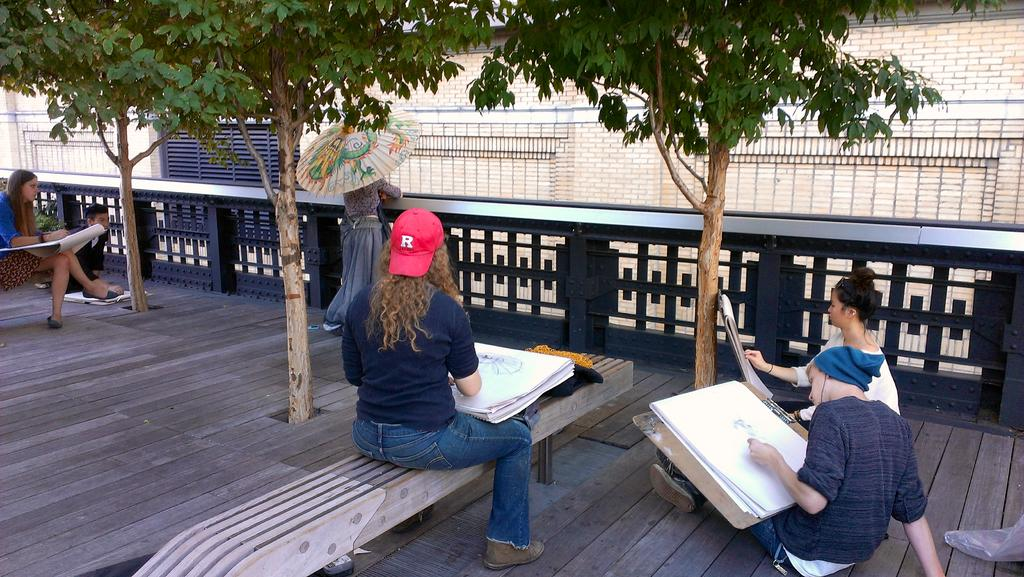Who or what can be seen in the image? There are people in the image. What are the people doing in the image? The people are on a path. What are the people holding in their hands? Most of the people are holding papers in their hands. How many trees are visible in the image? There are 3 trees in the image. What other object can be seen in the image? There is a fence in the image. What type of bells can be heard ringing in the image? There are no bells present in the image, and therefore no sound can be heard. 